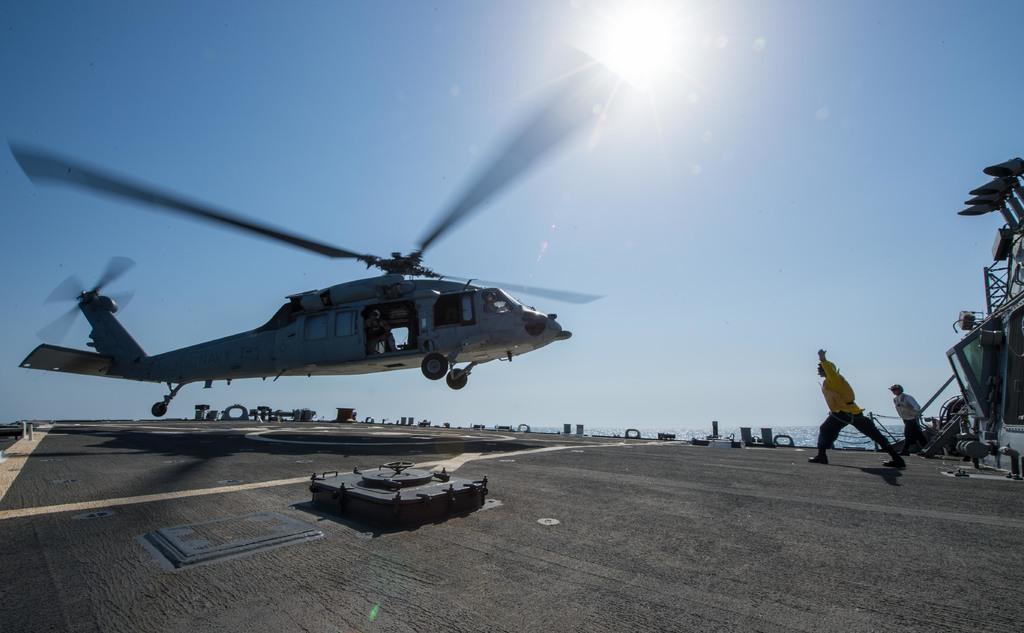In one or two sentences, can you explain what this image depicts? In this image, there are a few people. We can see a helicopter and the ground with some objects. We can also see some water and the sky. We can also see some objects on the right. 